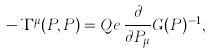<formula> <loc_0><loc_0><loc_500><loc_500>- i \Gamma ^ { \mu } ( P , P ) = Q e \, \frac { \partial } { \partial P _ { \mu } } G ( P ) ^ { - 1 } ,</formula> 